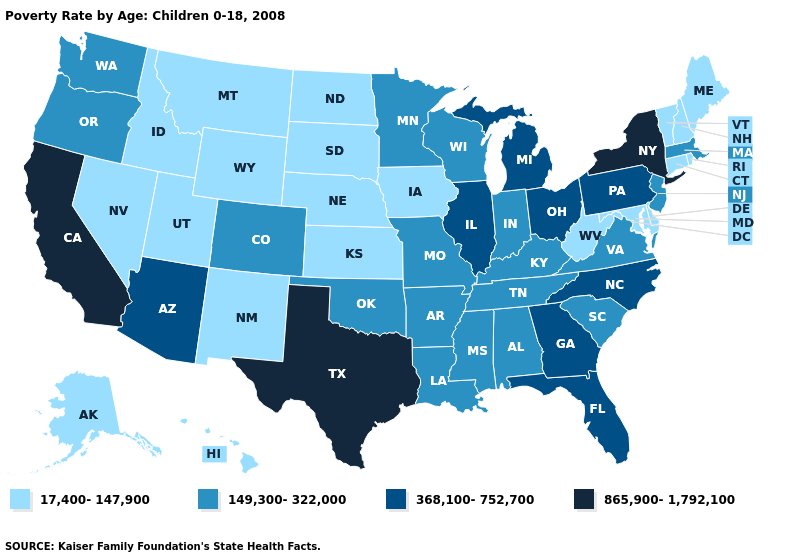Name the states that have a value in the range 149,300-322,000?
Write a very short answer. Alabama, Arkansas, Colorado, Indiana, Kentucky, Louisiana, Massachusetts, Minnesota, Mississippi, Missouri, New Jersey, Oklahoma, Oregon, South Carolina, Tennessee, Virginia, Washington, Wisconsin. Name the states that have a value in the range 17,400-147,900?
Give a very brief answer. Alaska, Connecticut, Delaware, Hawaii, Idaho, Iowa, Kansas, Maine, Maryland, Montana, Nebraska, Nevada, New Hampshire, New Mexico, North Dakota, Rhode Island, South Dakota, Utah, Vermont, West Virginia, Wyoming. Does the map have missing data?
Short answer required. No. Which states hav the highest value in the West?
Short answer required. California. Name the states that have a value in the range 865,900-1,792,100?
Give a very brief answer. California, New York, Texas. Does Nebraska have the same value as Vermont?
Write a very short answer. Yes. What is the value of Michigan?
Keep it brief. 368,100-752,700. What is the value of Pennsylvania?
Write a very short answer. 368,100-752,700. What is the lowest value in states that border Utah?
Short answer required. 17,400-147,900. Which states have the lowest value in the South?
Be succinct. Delaware, Maryland, West Virginia. What is the value of Maine?
Give a very brief answer. 17,400-147,900. Which states have the lowest value in the South?
Write a very short answer. Delaware, Maryland, West Virginia. Name the states that have a value in the range 149,300-322,000?
Answer briefly. Alabama, Arkansas, Colorado, Indiana, Kentucky, Louisiana, Massachusetts, Minnesota, Mississippi, Missouri, New Jersey, Oklahoma, Oregon, South Carolina, Tennessee, Virginia, Washington, Wisconsin. Which states hav the highest value in the Northeast?
Concise answer only. New York. Name the states that have a value in the range 149,300-322,000?
Give a very brief answer. Alabama, Arkansas, Colorado, Indiana, Kentucky, Louisiana, Massachusetts, Minnesota, Mississippi, Missouri, New Jersey, Oklahoma, Oregon, South Carolina, Tennessee, Virginia, Washington, Wisconsin. 